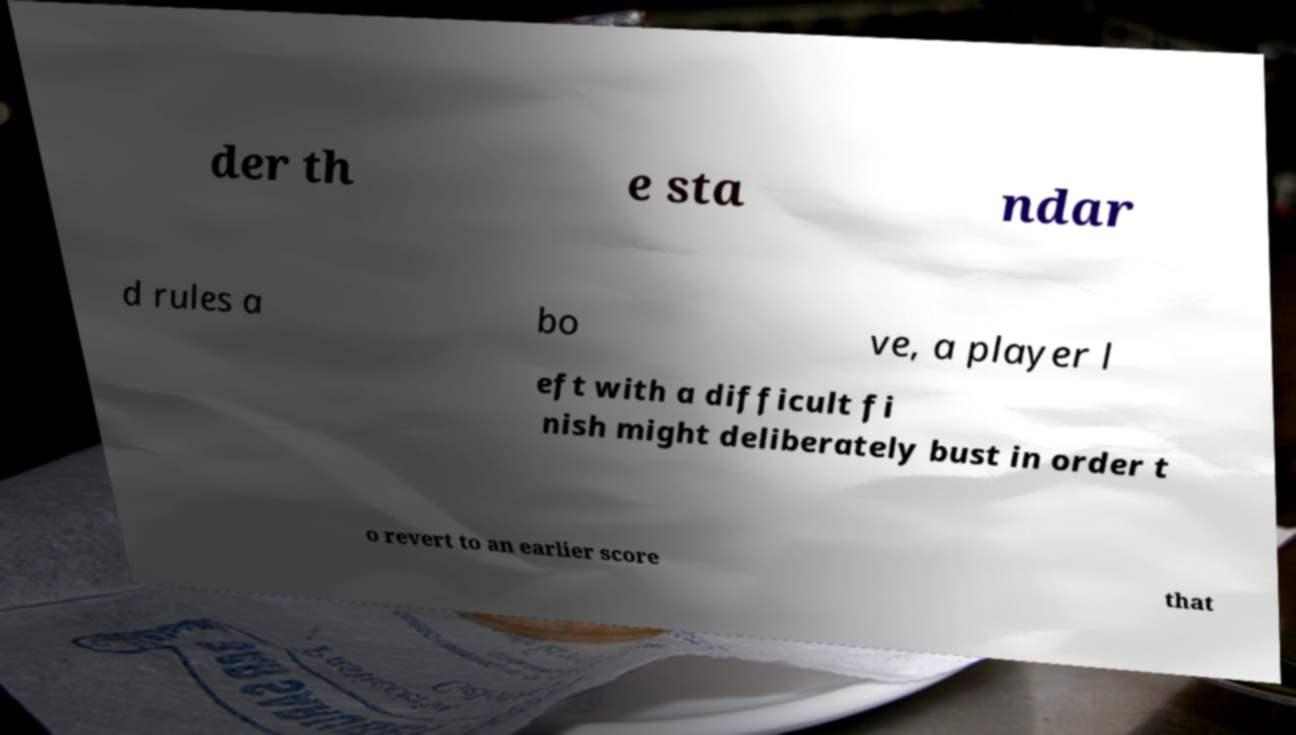There's text embedded in this image that I need extracted. Can you transcribe it verbatim? der th e sta ndar d rules a bo ve, a player l eft with a difficult fi nish might deliberately bust in order t o revert to an earlier score that 